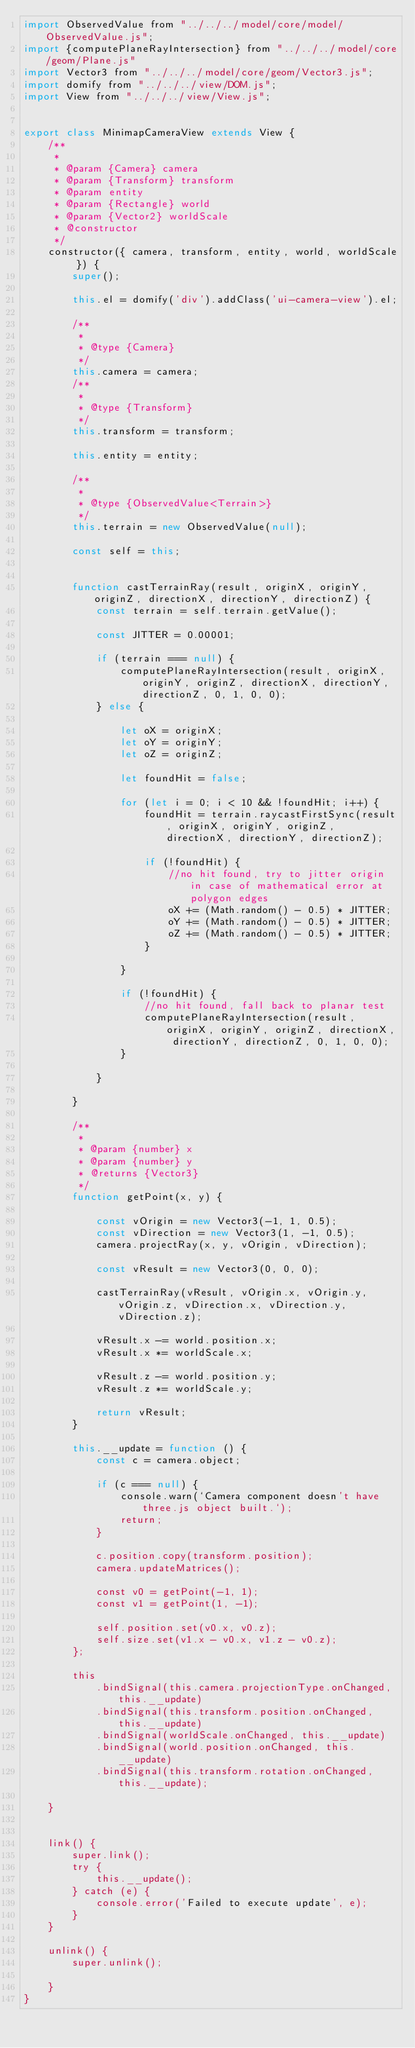<code> <loc_0><loc_0><loc_500><loc_500><_JavaScript_>import ObservedValue from "../../../model/core/model/ObservedValue.js";
import {computePlaneRayIntersection} from "../../../model/core/geom/Plane.js"
import Vector3 from "../../../model/core/geom/Vector3.js";
import domify from "../../../view/DOM.js";
import View from "../../../view/View.js";


export class MinimapCameraView extends View {
    /**
     *
     * @param {Camera} camera
     * @param {Transform} transform
     * @param entity
     * @param {Rectangle} world
     * @param {Vector2} worldScale
     * @constructor
     */
    constructor({ camera, transform, entity, world, worldScale }) {
        super();

        this.el = domify('div').addClass('ui-camera-view').el;

        /**
         *
         * @type {Camera}
         */
        this.camera = camera;
        /**
         *
         * @type {Transform}
         */
        this.transform = transform;

        this.entity = entity;

        /**
         *
         * @type {ObservedValue<Terrain>}
         */
        this.terrain = new ObservedValue(null);

        const self = this;


        function castTerrainRay(result, originX, originY, originZ, directionX, directionY, directionZ) {
            const terrain = self.terrain.getValue();

            const JITTER = 0.00001;

            if (terrain === null) {
                computePlaneRayIntersection(result, originX, originY, originZ, directionX, directionY, directionZ, 0, 1, 0, 0);
            } else {

                let oX = originX;
                let oY = originY;
                let oZ = originZ;

                let foundHit = false;

                for (let i = 0; i < 10 && !foundHit; i++) {
                    foundHit = terrain.raycastFirstSync(result, originX, originY, originZ, directionX, directionY, directionZ);

                    if (!foundHit) {
                        //no hit found, try to jitter origin in case of mathematical error at polygon edges
                        oX += (Math.random() - 0.5) * JITTER;
                        oY += (Math.random() - 0.5) * JITTER;
                        oZ += (Math.random() - 0.5) * JITTER;
                    }

                }

                if (!foundHit) {
                    //no hit found, fall back to planar test
                    computePlaneRayIntersection(result, originX, originY, originZ, directionX, directionY, directionZ, 0, 1, 0, 0);
                }

            }

        }

        /**
         *
         * @param {number} x
         * @param {number} y
         * @returns {Vector3}
         */
        function getPoint(x, y) {

            const vOrigin = new Vector3(-1, 1, 0.5);
            const vDirection = new Vector3(1, -1, 0.5);
            camera.projectRay(x, y, vOrigin, vDirection);

            const vResult = new Vector3(0, 0, 0);

            castTerrainRay(vResult, vOrigin.x, vOrigin.y, vOrigin.z, vDirection.x, vDirection.y, vDirection.z);

            vResult.x -= world.position.x;
            vResult.x *= worldScale.x;

            vResult.z -= world.position.y;
            vResult.z *= worldScale.y;

            return vResult;
        }

        this.__update = function () {
            const c = camera.object;

            if (c === null) {
                console.warn(`Camera component doesn't have three.js object built.`);
                return;
            }

            c.position.copy(transform.position);
            camera.updateMatrices();

            const v0 = getPoint(-1, 1);
            const v1 = getPoint(1, -1);

            self.position.set(v0.x, v0.z);
            self.size.set(v1.x - v0.x, v1.z - v0.z);
        };

        this
            .bindSignal(this.camera.projectionType.onChanged, this.__update)
            .bindSignal(this.transform.position.onChanged, this.__update)
            .bindSignal(worldScale.onChanged, this.__update)
            .bindSignal(world.position.onChanged, this.__update)
            .bindSignal(this.transform.rotation.onChanged, this.__update);

    }


    link() {
        super.link();
        try {
            this.__update();
        } catch (e) {
            console.error('Failed to execute update', e);
        }
    }

    unlink() {
        super.unlink();

    }
}



</code> 